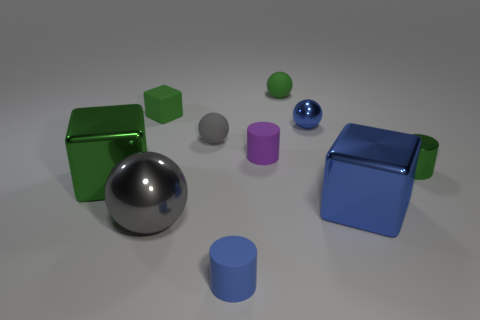What number of small metal objects have the same color as the rubber block?
Your answer should be very brief. 1. Is there anything else that is the same size as the blue metallic ball?
Your response must be concise. Yes. Do the small metallic cylinder and the metallic block in front of the large green shiny object have the same color?
Offer a very short reply. No. Are there the same number of things left of the purple cylinder and blue rubber objects behind the large metal sphere?
Your answer should be very brief. No. There is a cube that is on the right side of the green rubber cube; what is its material?
Offer a very short reply. Metal. What number of objects are either tiny cylinders that are behind the gray shiny object or tiny gray balls?
Offer a very short reply. 3. How many other things are the same shape as the small gray thing?
Provide a succinct answer. 3. Is the shape of the big metal thing to the right of the tiny blue cylinder the same as  the large gray shiny thing?
Your answer should be compact. No. Are there any big cubes in front of the big gray metal thing?
Your answer should be very brief. No. What number of large things are gray things or gray cylinders?
Your response must be concise. 1. 